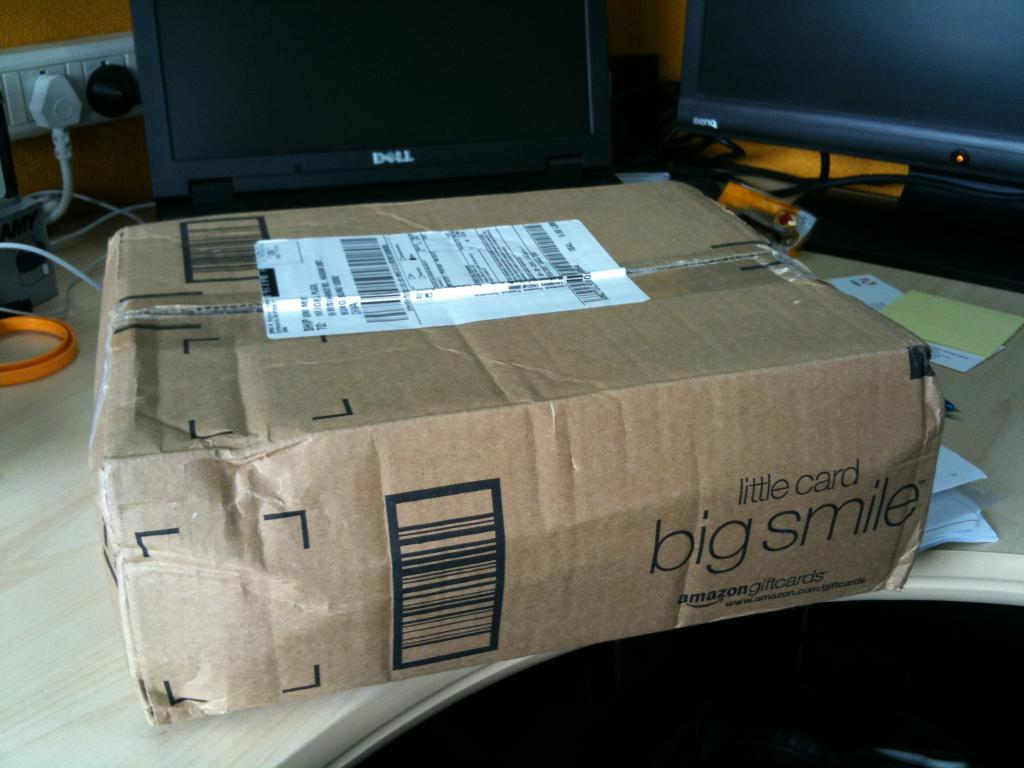<image>
Summarize the visual content of the image. A package sitting on a computer desk from Amazon. 